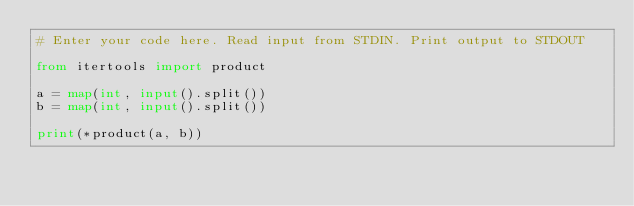Convert code to text. <code><loc_0><loc_0><loc_500><loc_500><_Python_># Enter your code here. Read input from STDIN. Print output to STDOUT

from itertools import product

a = map(int, input().split())
b = map(int, input().split())

print(*product(a, b))

</code> 